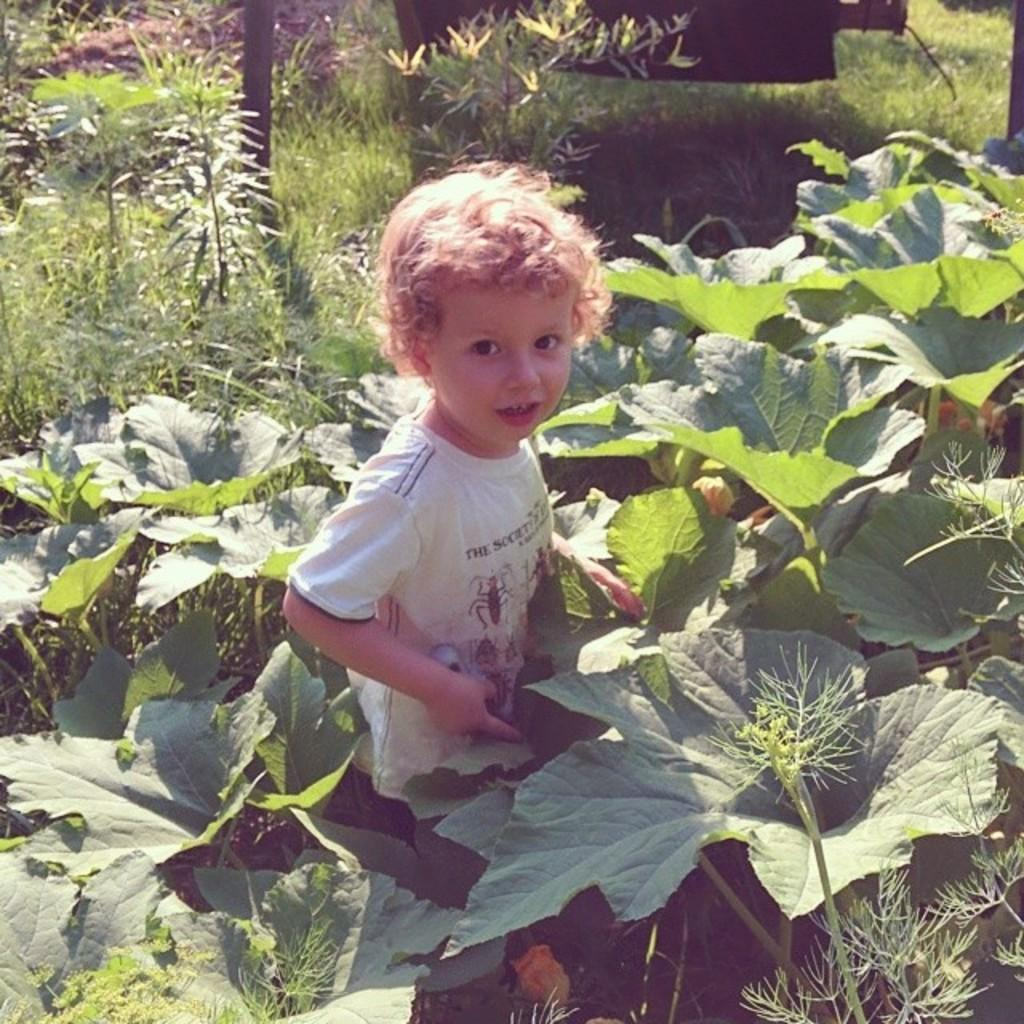What is the main subject of the image? There is a child in the image. What can be seen near the child? There are plants near the child. What type of underwear is the child wearing in the image? There is no information about the child's underwear in the image, so it cannot be determined. 